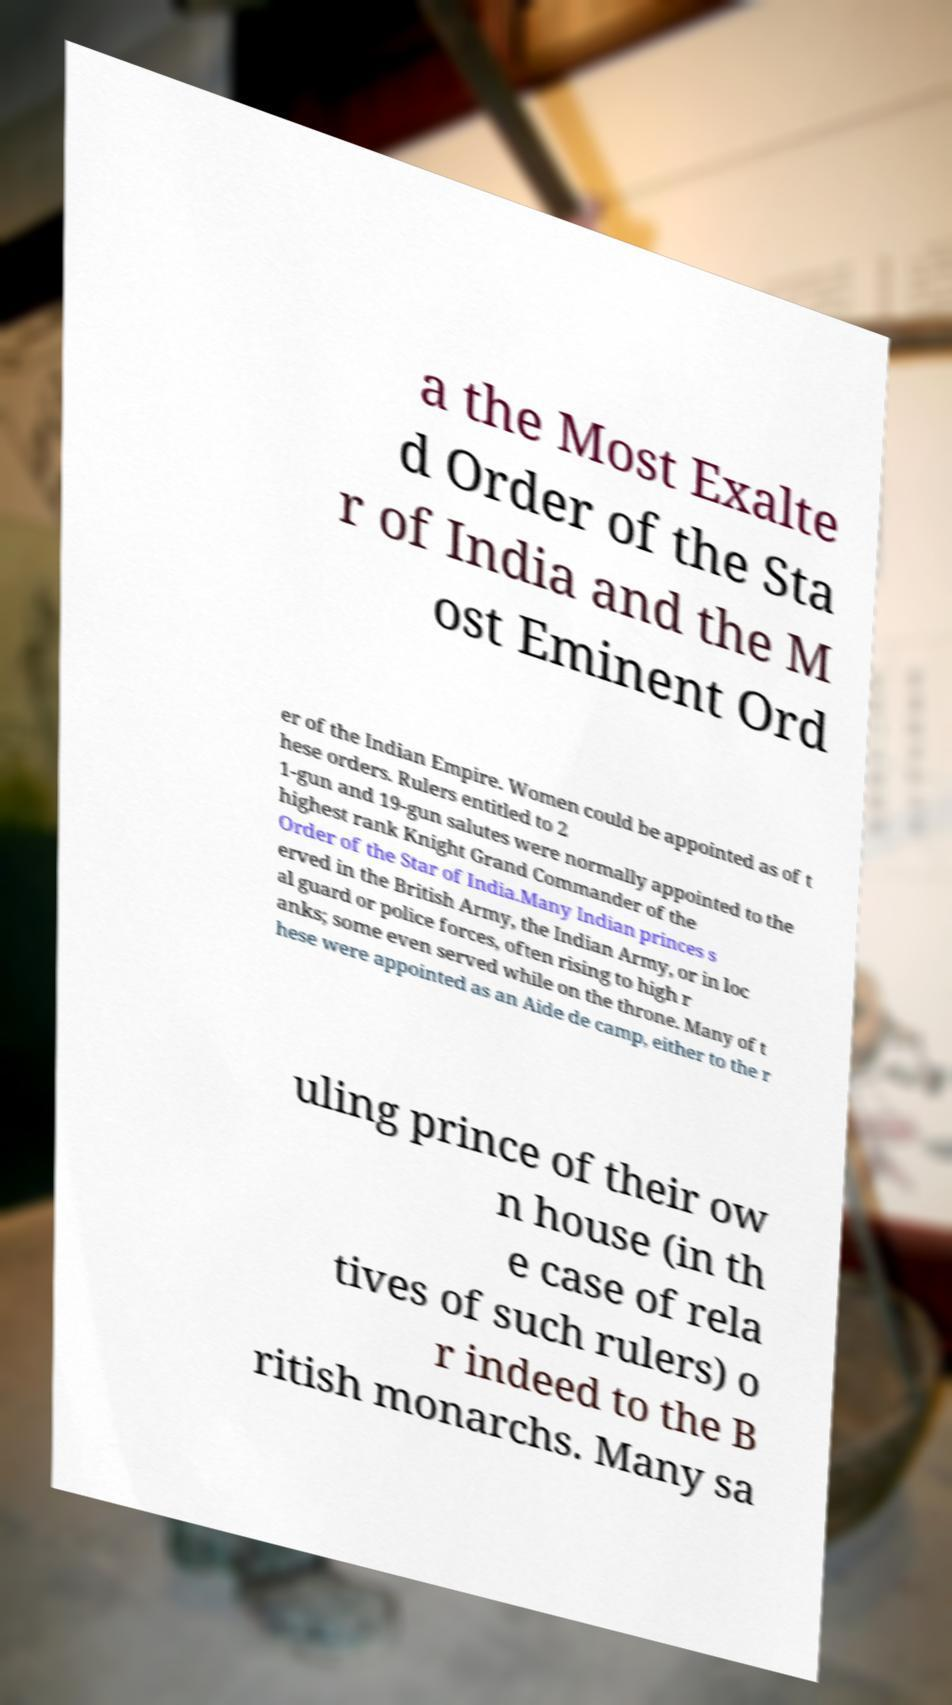Could you assist in decoding the text presented in this image and type it out clearly? a the Most Exalte d Order of the Sta r of India and the M ost Eminent Ord er of the Indian Empire. Women could be appointed as of t hese orders. Rulers entitled to 2 1-gun and 19-gun salutes were normally appointed to the highest rank Knight Grand Commander of the Order of the Star of India.Many Indian princes s erved in the British Army, the Indian Army, or in loc al guard or police forces, often rising to high r anks; some even served while on the throne. Many of t hese were appointed as an Aide de camp, either to the r uling prince of their ow n house (in th e case of rela tives of such rulers) o r indeed to the B ritish monarchs. Many sa 